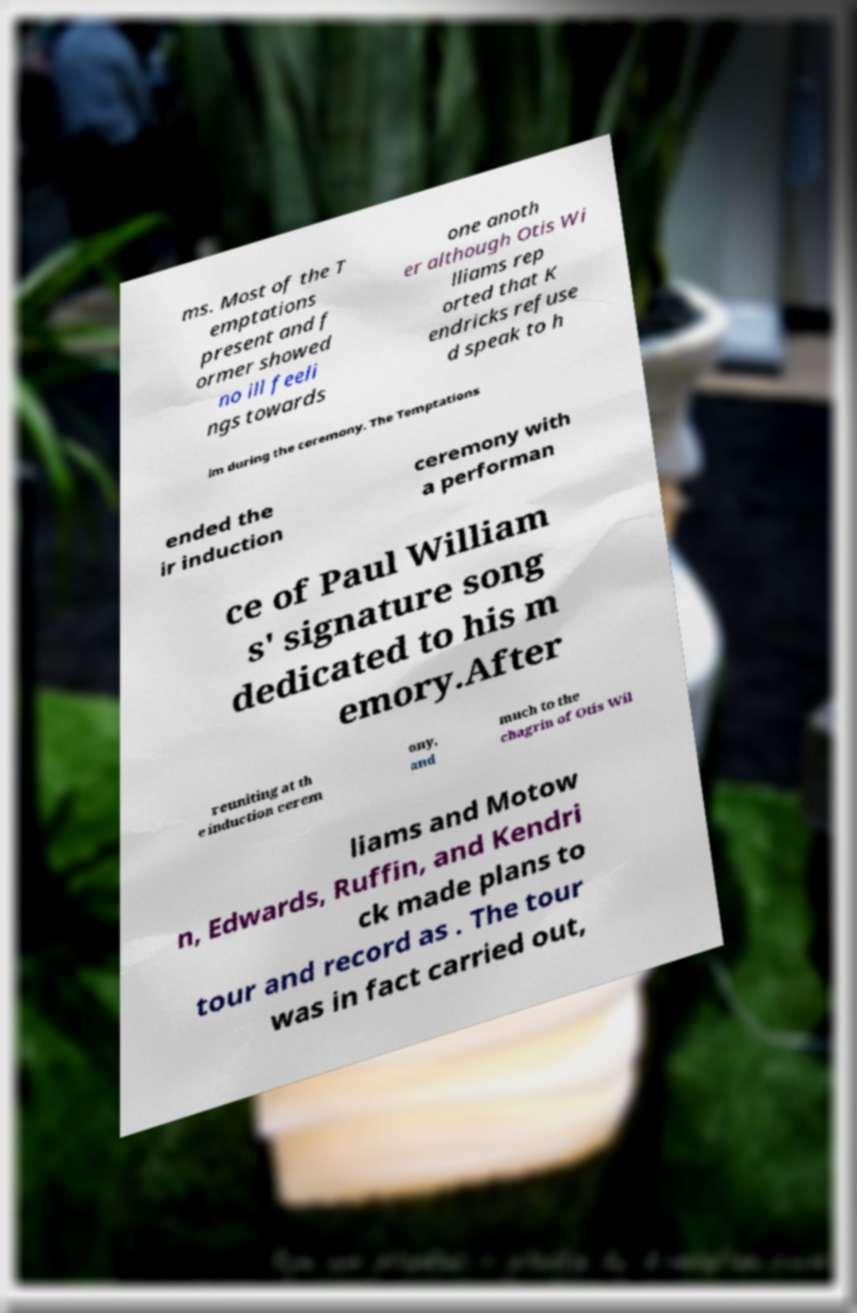For documentation purposes, I need the text within this image transcribed. Could you provide that? ms. Most of the T emptations present and f ormer showed no ill feeli ngs towards one anoth er although Otis Wi lliams rep orted that K endricks refuse d speak to h im during the ceremony. The Temptations ended the ir induction ceremony with a performan ce of Paul William s' signature song dedicated to his m emory.After reuniting at th e induction cerem ony, and much to the chagrin of Otis Wil liams and Motow n, Edwards, Ruffin, and Kendri ck made plans to tour and record as . The tour was in fact carried out, 